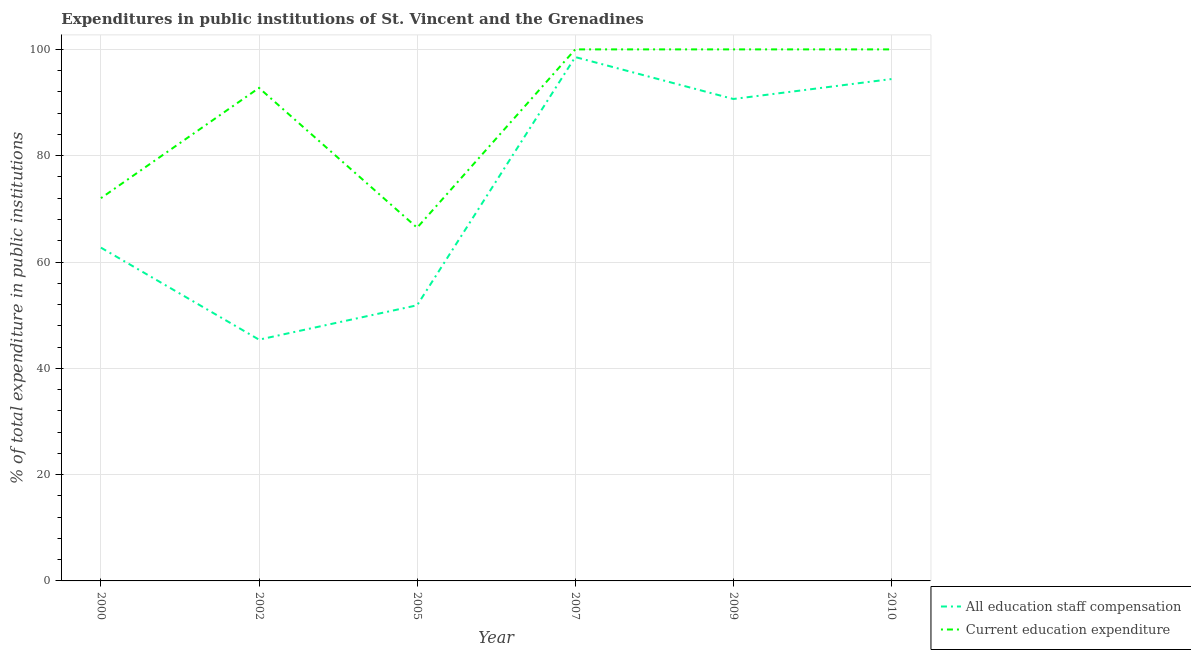How many different coloured lines are there?
Offer a terse response. 2. What is the expenditure in staff compensation in 2005?
Your response must be concise. 51.86. Across all years, what is the minimum expenditure in staff compensation?
Provide a short and direct response. 45.39. In which year was the expenditure in staff compensation maximum?
Give a very brief answer. 2007. What is the total expenditure in staff compensation in the graph?
Keep it short and to the point. 443.59. What is the difference between the expenditure in education in 2000 and that in 2007?
Give a very brief answer. -27.99. What is the difference between the expenditure in education in 2002 and the expenditure in staff compensation in 2007?
Make the answer very short. -5.8. What is the average expenditure in staff compensation per year?
Offer a terse response. 73.93. In the year 2010, what is the difference between the expenditure in education and expenditure in staff compensation?
Keep it short and to the point. 5.58. What is the ratio of the expenditure in education in 2000 to that in 2007?
Your answer should be very brief. 0.72. Is the expenditure in education in 2000 less than that in 2009?
Ensure brevity in your answer.  Yes. What is the difference between the highest and the second highest expenditure in education?
Provide a succinct answer. 0. What is the difference between the highest and the lowest expenditure in education?
Provide a succinct answer. 33.55. In how many years, is the expenditure in education greater than the average expenditure in education taken over all years?
Make the answer very short. 4. Is the sum of the expenditure in staff compensation in 2005 and 2010 greater than the maximum expenditure in education across all years?
Keep it short and to the point. Yes. Does the expenditure in education monotonically increase over the years?
Provide a short and direct response. No. Is the expenditure in education strictly less than the expenditure in staff compensation over the years?
Your answer should be compact. No. How many years are there in the graph?
Keep it short and to the point. 6. What is the difference between two consecutive major ticks on the Y-axis?
Your answer should be compact. 20. Does the graph contain any zero values?
Ensure brevity in your answer.  No. Does the graph contain grids?
Make the answer very short. Yes. Where does the legend appear in the graph?
Keep it short and to the point. Bottom right. How are the legend labels stacked?
Make the answer very short. Vertical. What is the title of the graph?
Keep it short and to the point. Expenditures in public institutions of St. Vincent and the Grenadines. Does "Grants" appear as one of the legend labels in the graph?
Ensure brevity in your answer.  No. What is the label or title of the Y-axis?
Offer a terse response. % of total expenditure in public institutions. What is the % of total expenditure in public institutions of All education staff compensation in 2000?
Ensure brevity in your answer.  62.7. What is the % of total expenditure in public institutions of Current education expenditure in 2000?
Your answer should be compact. 72.01. What is the % of total expenditure in public institutions of All education staff compensation in 2002?
Offer a terse response. 45.39. What is the % of total expenditure in public institutions in Current education expenditure in 2002?
Keep it short and to the point. 92.75. What is the % of total expenditure in public institutions in All education staff compensation in 2005?
Your answer should be compact. 51.86. What is the % of total expenditure in public institutions of Current education expenditure in 2005?
Offer a very short reply. 66.45. What is the % of total expenditure in public institutions in All education staff compensation in 2007?
Offer a terse response. 98.56. What is the % of total expenditure in public institutions in All education staff compensation in 2009?
Keep it short and to the point. 90.67. What is the % of total expenditure in public institutions of All education staff compensation in 2010?
Ensure brevity in your answer.  94.42. Across all years, what is the maximum % of total expenditure in public institutions of All education staff compensation?
Your answer should be compact. 98.56. Across all years, what is the maximum % of total expenditure in public institutions of Current education expenditure?
Make the answer very short. 100. Across all years, what is the minimum % of total expenditure in public institutions in All education staff compensation?
Keep it short and to the point. 45.39. Across all years, what is the minimum % of total expenditure in public institutions in Current education expenditure?
Provide a succinct answer. 66.45. What is the total % of total expenditure in public institutions of All education staff compensation in the graph?
Provide a short and direct response. 443.59. What is the total % of total expenditure in public institutions of Current education expenditure in the graph?
Your response must be concise. 531.21. What is the difference between the % of total expenditure in public institutions in All education staff compensation in 2000 and that in 2002?
Keep it short and to the point. 17.31. What is the difference between the % of total expenditure in public institutions of Current education expenditure in 2000 and that in 2002?
Give a very brief answer. -20.74. What is the difference between the % of total expenditure in public institutions of All education staff compensation in 2000 and that in 2005?
Your response must be concise. 10.85. What is the difference between the % of total expenditure in public institutions of Current education expenditure in 2000 and that in 2005?
Make the answer very short. 5.56. What is the difference between the % of total expenditure in public institutions of All education staff compensation in 2000 and that in 2007?
Provide a short and direct response. -35.85. What is the difference between the % of total expenditure in public institutions in Current education expenditure in 2000 and that in 2007?
Offer a terse response. -27.99. What is the difference between the % of total expenditure in public institutions in All education staff compensation in 2000 and that in 2009?
Keep it short and to the point. -27.96. What is the difference between the % of total expenditure in public institutions in Current education expenditure in 2000 and that in 2009?
Ensure brevity in your answer.  -27.99. What is the difference between the % of total expenditure in public institutions in All education staff compensation in 2000 and that in 2010?
Provide a succinct answer. -31.71. What is the difference between the % of total expenditure in public institutions of Current education expenditure in 2000 and that in 2010?
Provide a succinct answer. -27.99. What is the difference between the % of total expenditure in public institutions in All education staff compensation in 2002 and that in 2005?
Give a very brief answer. -6.47. What is the difference between the % of total expenditure in public institutions in Current education expenditure in 2002 and that in 2005?
Your answer should be compact. 26.3. What is the difference between the % of total expenditure in public institutions of All education staff compensation in 2002 and that in 2007?
Provide a short and direct response. -53.17. What is the difference between the % of total expenditure in public institutions in Current education expenditure in 2002 and that in 2007?
Offer a terse response. -7.25. What is the difference between the % of total expenditure in public institutions in All education staff compensation in 2002 and that in 2009?
Your response must be concise. -45.28. What is the difference between the % of total expenditure in public institutions of Current education expenditure in 2002 and that in 2009?
Offer a terse response. -7.25. What is the difference between the % of total expenditure in public institutions of All education staff compensation in 2002 and that in 2010?
Provide a succinct answer. -49.03. What is the difference between the % of total expenditure in public institutions in Current education expenditure in 2002 and that in 2010?
Give a very brief answer. -7.25. What is the difference between the % of total expenditure in public institutions of All education staff compensation in 2005 and that in 2007?
Ensure brevity in your answer.  -46.7. What is the difference between the % of total expenditure in public institutions of Current education expenditure in 2005 and that in 2007?
Ensure brevity in your answer.  -33.55. What is the difference between the % of total expenditure in public institutions in All education staff compensation in 2005 and that in 2009?
Provide a succinct answer. -38.81. What is the difference between the % of total expenditure in public institutions in Current education expenditure in 2005 and that in 2009?
Offer a terse response. -33.55. What is the difference between the % of total expenditure in public institutions in All education staff compensation in 2005 and that in 2010?
Keep it short and to the point. -42.56. What is the difference between the % of total expenditure in public institutions of Current education expenditure in 2005 and that in 2010?
Your answer should be very brief. -33.55. What is the difference between the % of total expenditure in public institutions of All education staff compensation in 2007 and that in 2009?
Offer a very short reply. 7.89. What is the difference between the % of total expenditure in public institutions of Current education expenditure in 2007 and that in 2009?
Provide a short and direct response. 0. What is the difference between the % of total expenditure in public institutions of All education staff compensation in 2007 and that in 2010?
Offer a very short reply. 4.14. What is the difference between the % of total expenditure in public institutions of All education staff compensation in 2009 and that in 2010?
Provide a short and direct response. -3.75. What is the difference between the % of total expenditure in public institutions in Current education expenditure in 2009 and that in 2010?
Ensure brevity in your answer.  0. What is the difference between the % of total expenditure in public institutions in All education staff compensation in 2000 and the % of total expenditure in public institutions in Current education expenditure in 2002?
Your response must be concise. -30.05. What is the difference between the % of total expenditure in public institutions of All education staff compensation in 2000 and the % of total expenditure in public institutions of Current education expenditure in 2005?
Your response must be concise. -3.74. What is the difference between the % of total expenditure in public institutions of All education staff compensation in 2000 and the % of total expenditure in public institutions of Current education expenditure in 2007?
Provide a short and direct response. -37.3. What is the difference between the % of total expenditure in public institutions in All education staff compensation in 2000 and the % of total expenditure in public institutions in Current education expenditure in 2009?
Ensure brevity in your answer.  -37.3. What is the difference between the % of total expenditure in public institutions in All education staff compensation in 2000 and the % of total expenditure in public institutions in Current education expenditure in 2010?
Provide a short and direct response. -37.3. What is the difference between the % of total expenditure in public institutions in All education staff compensation in 2002 and the % of total expenditure in public institutions in Current education expenditure in 2005?
Make the answer very short. -21.06. What is the difference between the % of total expenditure in public institutions in All education staff compensation in 2002 and the % of total expenditure in public institutions in Current education expenditure in 2007?
Make the answer very short. -54.61. What is the difference between the % of total expenditure in public institutions of All education staff compensation in 2002 and the % of total expenditure in public institutions of Current education expenditure in 2009?
Make the answer very short. -54.61. What is the difference between the % of total expenditure in public institutions of All education staff compensation in 2002 and the % of total expenditure in public institutions of Current education expenditure in 2010?
Your answer should be very brief. -54.61. What is the difference between the % of total expenditure in public institutions of All education staff compensation in 2005 and the % of total expenditure in public institutions of Current education expenditure in 2007?
Your answer should be compact. -48.14. What is the difference between the % of total expenditure in public institutions of All education staff compensation in 2005 and the % of total expenditure in public institutions of Current education expenditure in 2009?
Keep it short and to the point. -48.14. What is the difference between the % of total expenditure in public institutions of All education staff compensation in 2005 and the % of total expenditure in public institutions of Current education expenditure in 2010?
Give a very brief answer. -48.14. What is the difference between the % of total expenditure in public institutions of All education staff compensation in 2007 and the % of total expenditure in public institutions of Current education expenditure in 2009?
Your answer should be compact. -1.44. What is the difference between the % of total expenditure in public institutions of All education staff compensation in 2007 and the % of total expenditure in public institutions of Current education expenditure in 2010?
Ensure brevity in your answer.  -1.44. What is the difference between the % of total expenditure in public institutions in All education staff compensation in 2009 and the % of total expenditure in public institutions in Current education expenditure in 2010?
Your answer should be compact. -9.33. What is the average % of total expenditure in public institutions of All education staff compensation per year?
Provide a short and direct response. 73.93. What is the average % of total expenditure in public institutions in Current education expenditure per year?
Offer a terse response. 88.53. In the year 2000, what is the difference between the % of total expenditure in public institutions in All education staff compensation and % of total expenditure in public institutions in Current education expenditure?
Make the answer very short. -9.3. In the year 2002, what is the difference between the % of total expenditure in public institutions of All education staff compensation and % of total expenditure in public institutions of Current education expenditure?
Offer a very short reply. -47.36. In the year 2005, what is the difference between the % of total expenditure in public institutions in All education staff compensation and % of total expenditure in public institutions in Current education expenditure?
Make the answer very short. -14.59. In the year 2007, what is the difference between the % of total expenditure in public institutions in All education staff compensation and % of total expenditure in public institutions in Current education expenditure?
Make the answer very short. -1.44. In the year 2009, what is the difference between the % of total expenditure in public institutions of All education staff compensation and % of total expenditure in public institutions of Current education expenditure?
Give a very brief answer. -9.33. In the year 2010, what is the difference between the % of total expenditure in public institutions in All education staff compensation and % of total expenditure in public institutions in Current education expenditure?
Your response must be concise. -5.58. What is the ratio of the % of total expenditure in public institutions of All education staff compensation in 2000 to that in 2002?
Keep it short and to the point. 1.38. What is the ratio of the % of total expenditure in public institutions in Current education expenditure in 2000 to that in 2002?
Keep it short and to the point. 0.78. What is the ratio of the % of total expenditure in public institutions in All education staff compensation in 2000 to that in 2005?
Your answer should be very brief. 1.21. What is the ratio of the % of total expenditure in public institutions of Current education expenditure in 2000 to that in 2005?
Ensure brevity in your answer.  1.08. What is the ratio of the % of total expenditure in public institutions in All education staff compensation in 2000 to that in 2007?
Offer a very short reply. 0.64. What is the ratio of the % of total expenditure in public institutions of Current education expenditure in 2000 to that in 2007?
Offer a very short reply. 0.72. What is the ratio of the % of total expenditure in public institutions of All education staff compensation in 2000 to that in 2009?
Your answer should be compact. 0.69. What is the ratio of the % of total expenditure in public institutions of Current education expenditure in 2000 to that in 2009?
Offer a terse response. 0.72. What is the ratio of the % of total expenditure in public institutions in All education staff compensation in 2000 to that in 2010?
Your answer should be compact. 0.66. What is the ratio of the % of total expenditure in public institutions of Current education expenditure in 2000 to that in 2010?
Offer a very short reply. 0.72. What is the ratio of the % of total expenditure in public institutions in All education staff compensation in 2002 to that in 2005?
Your answer should be very brief. 0.88. What is the ratio of the % of total expenditure in public institutions in Current education expenditure in 2002 to that in 2005?
Give a very brief answer. 1.4. What is the ratio of the % of total expenditure in public institutions in All education staff compensation in 2002 to that in 2007?
Offer a very short reply. 0.46. What is the ratio of the % of total expenditure in public institutions in Current education expenditure in 2002 to that in 2007?
Provide a short and direct response. 0.93. What is the ratio of the % of total expenditure in public institutions of All education staff compensation in 2002 to that in 2009?
Your response must be concise. 0.5. What is the ratio of the % of total expenditure in public institutions of Current education expenditure in 2002 to that in 2009?
Your answer should be compact. 0.93. What is the ratio of the % of total expenditure in public institutions of All education staff compensation in 2002 to that in 2010?
Your answer should be very brief. 0.48. What is the ratio of the % of total expenditure in public institutions of Current education expenditure in 2002 to that in 2010?
Your response must be concise. 0.93. What is the ratio of the % of total expenditure in public institutions in All education staff compensation in 2005 to that in 2007?
Ensure brevity in your answer.  0.53. What is the ratio of the % of total expenditure in public institutions in Current education expenditure in 2005 to that in 2007?
Your answer should be compact. 0.66. What is the ratio of the % of total expenditure in public institutions in All education staff compensation in 2005 to that in 2009?
Your answer should be compact. 0.57. What is the ratio of the % of total expenditure in public institutions of Current education expenditure in 2005 to that in 2009?
Ensure brevity in your answer.  0.66. What is the ratio of the % of total expenditure in public institutions of All education staff compensation in 2005 to that in 2010?
Ensure brevity in your answer.  0.55. What is the ratio of the % of total expenditure in public institutions in Current education expenditure in 2005 to that in 2010?
Offer a very short reply. 0.66. What is the ratio of the % of total expenditure in public institutions in All education staff compensation in 2007 to that in 2009?
Ensure brevity in your answer.  1.09. What is the ratio of the % of total expenditure in public institutions of Current education expenditure in 2007 to that in 2009?
Provide a succinct answer. 1. What is the ratio of the % of total expenditure in public institutions in All education staff compensation in 2007 to that in 2010?
Make the answer very short. 1.04. What is the ratio of the % of total expenditure in public institutions in All education staff compensation in 2009 to that in 2010?
Provide a short and direct response. 0.96. What is the difference between the highest and the second highest % of total expenditure in public institutions in All education staff compensation?
Your answer should be compact. 4.14. What is the difference between the highest and the second highest % of total expenditure in public institutions of Current education expenditure?
Provide a short and direct response. 0. What is the difference between the highest and the lowest % of total expenditure in public institutions in All education staff compensation?
Provide a succinct answer. 53.17. What is the difference between the highest and the lowest % of total expenditure in public institutions of Current education expenditure?
Keep it short and to the point. 33.55. 